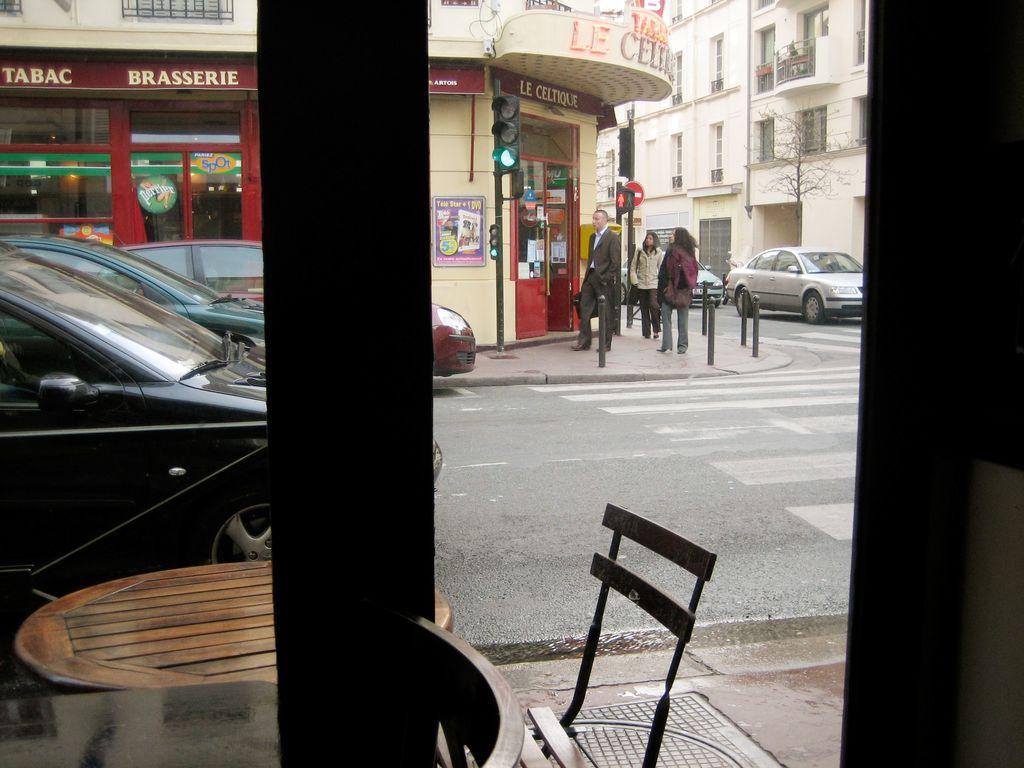Can you describe this image briefly? In this image I can see a chair and people on the road. I can also see vehicles on the road, poles, buildings and some other objects on the ground. Here I can see a tree, a table and other objects on the ground. 